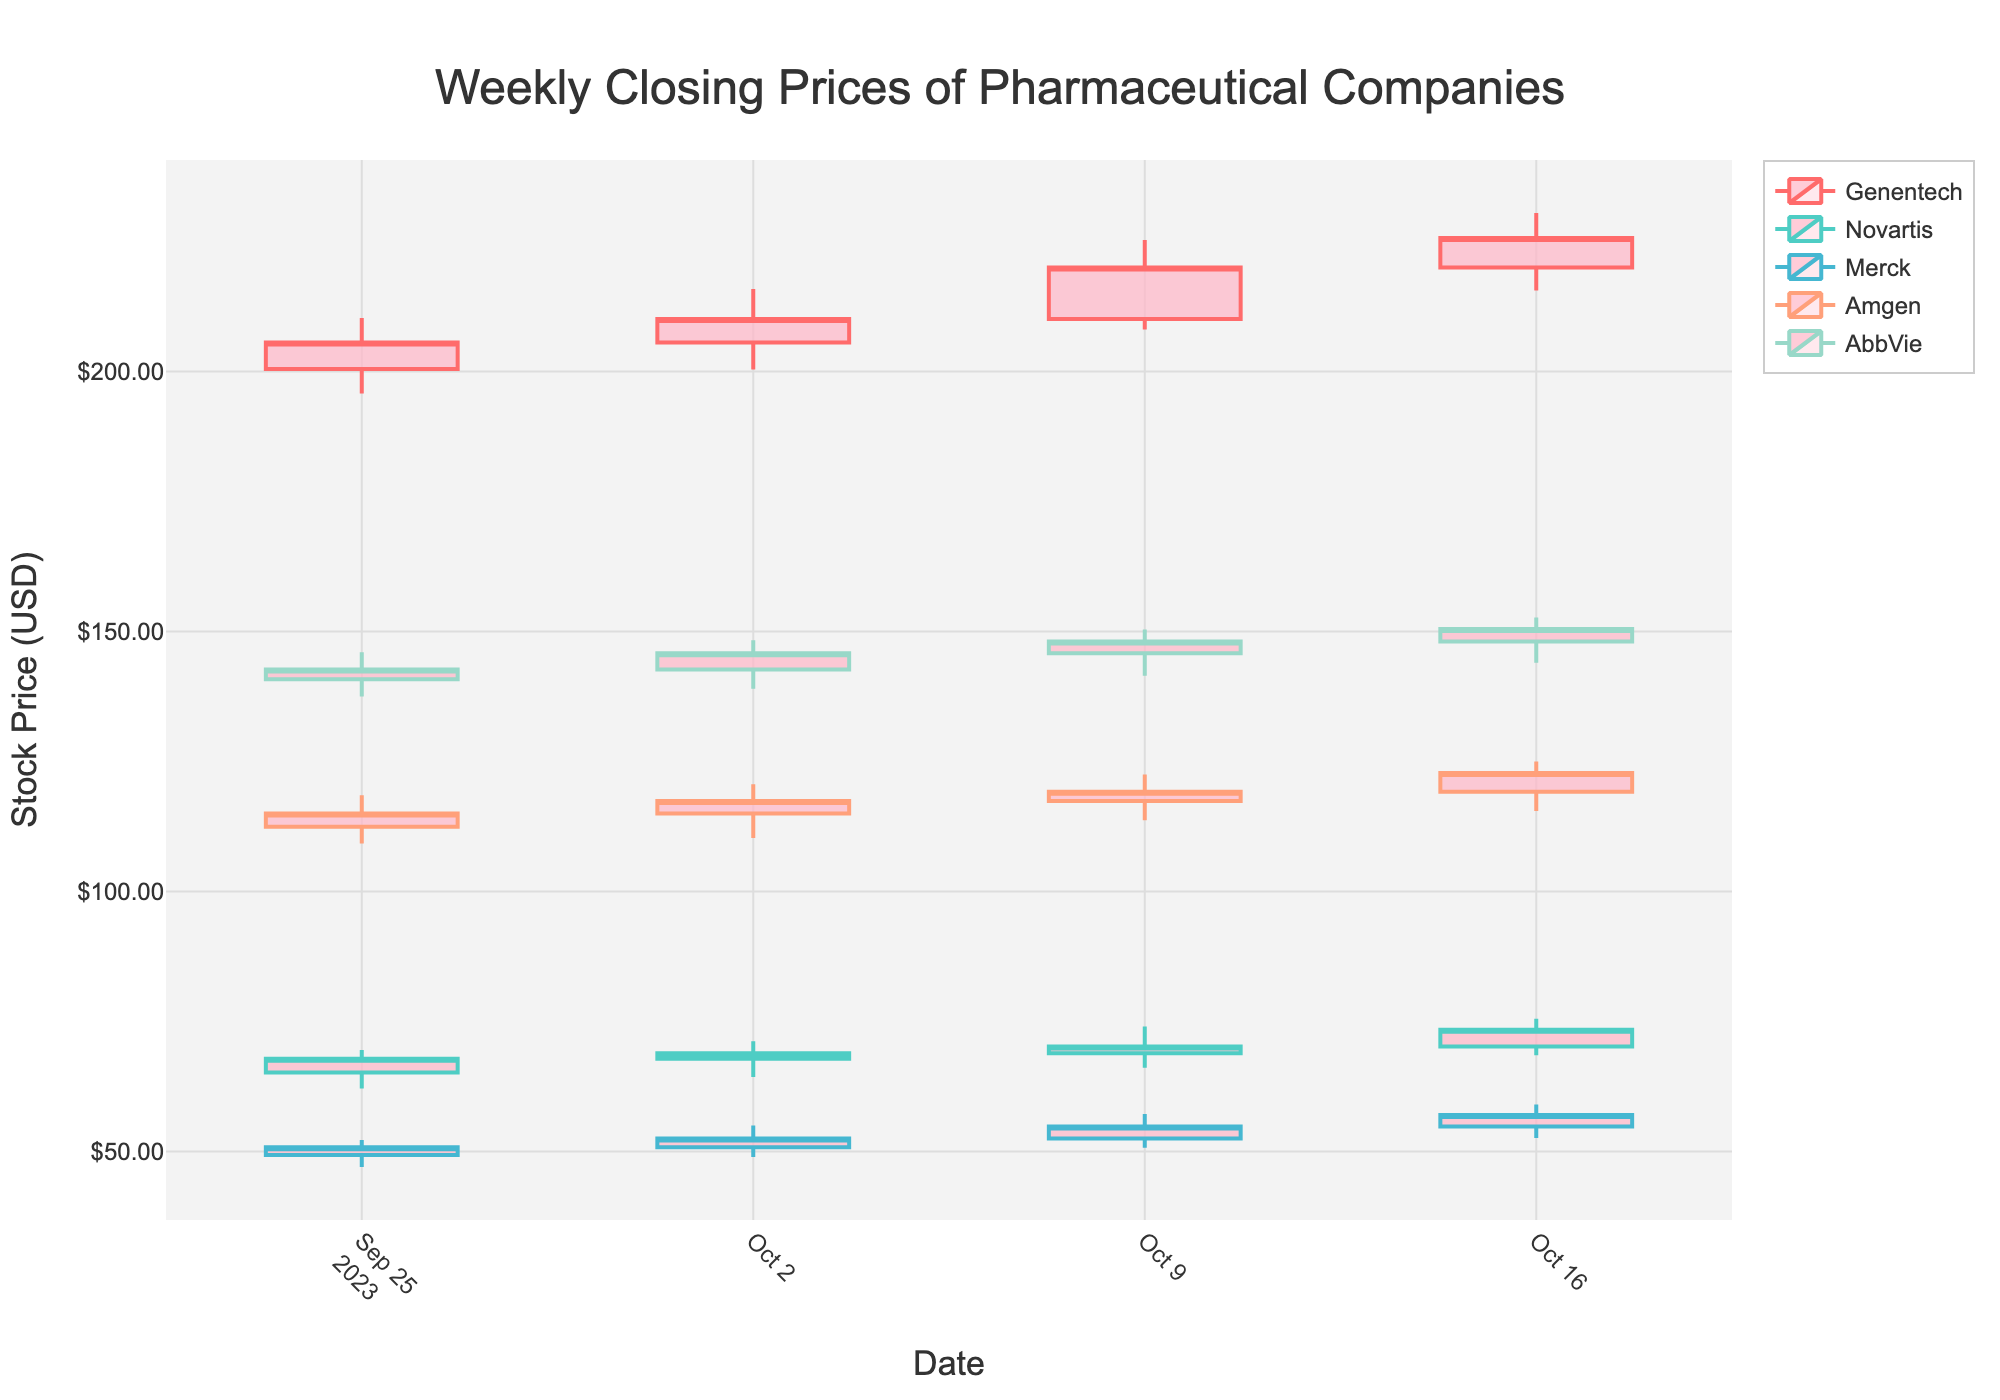What is the title of the plot? The title of the plot is located at the top center of the figure.
Answer: Weekly Closing Prices of Pharmaceutical Companies What is the color used to represent the candlestick of Genentech? The color representing Genentech is used in the candlestick traces for this company.
Answer: #FF6B6B What is the highest closing price for AbbVie in the given period? Look at the highest point in the close column for AbbVie. The highest closing price occurs on 2023-10-16.
Answer: $150.50 Which company had the highest stock price on October 16, 2023? Check the stock prices for all companies on 2023-10-16. Genentech had the highest at $225.70.
Answer: Genentech Which company showed an increasing trend for four consecutive weeks? Analyze the closing prices for each company across all four weeks. Genentech shows a continuous increase from 2023-09-25 to 2023-10-16.
Answer: Genentech What is the total volume of shares traded by Merck over the period? Sum the volume of trades for Merck across all rows. (460500 + 500900 + 540600 + 590300 = 2092300)
Answer: 2,092,300 What is the average closing price of Amgen over the four weeks? Calculate the average of Amgen's closing prices. (115.00 + 117.40 + 119.20 + 122.80) / 4
Answer: $118.10 Did Novartis' stock ever fall below $65.00? Look at the low prices of Novartis across all weeks. The lowest is $62.10 on 2023-09-25.
Answer: Yes Which company had the largest range (difference between high and low) in the week of October 9, 2023? Calculate the difference between high and low for each company for the week of October 9, 2023. Genentech had the largest (225.30 - 208.10 = 17.20).
Answer: Genentech Which company experienced a price decrease from October 9, 2023 to October 16, 2023? Compare the closing prices on October 9 and October 16 for all companies. None had a decrease.
Answer: None 